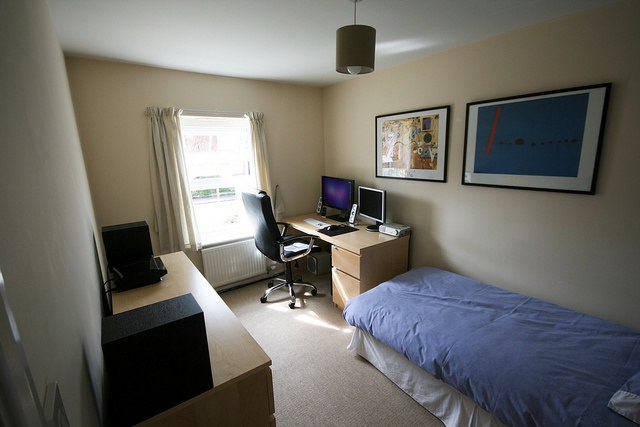Describe the objects in this image and their specific colors. I can see bed in black and gray tones, chair in black, gray, lightgray, and darkgray tones, tv in black, navy, purple, and gray tones, tv in black, gray, darkgray, and lightgray tones, and keyboard in black, lightgray, darkgray, and gray tones in this image. 